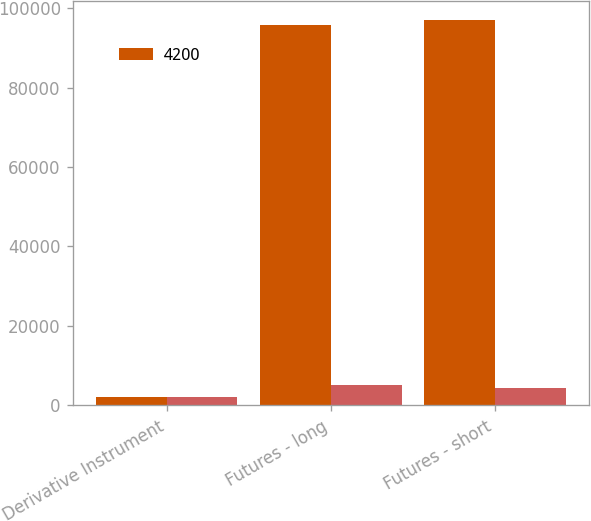Convert chart to OTSL. <chart><loc_0><loc_0><loc_500><loc_500><stacked_bar_chart><ecel><fcel>Derivative Instrument<fcel>Futures - long<fcel>Futures - short<nl><fcel>4200<fcel>2015<fcel>95709<fcel>96897<nl><fcel>nan<fcel>2016<fcel>5116<fcel>4341<nl></chart> 